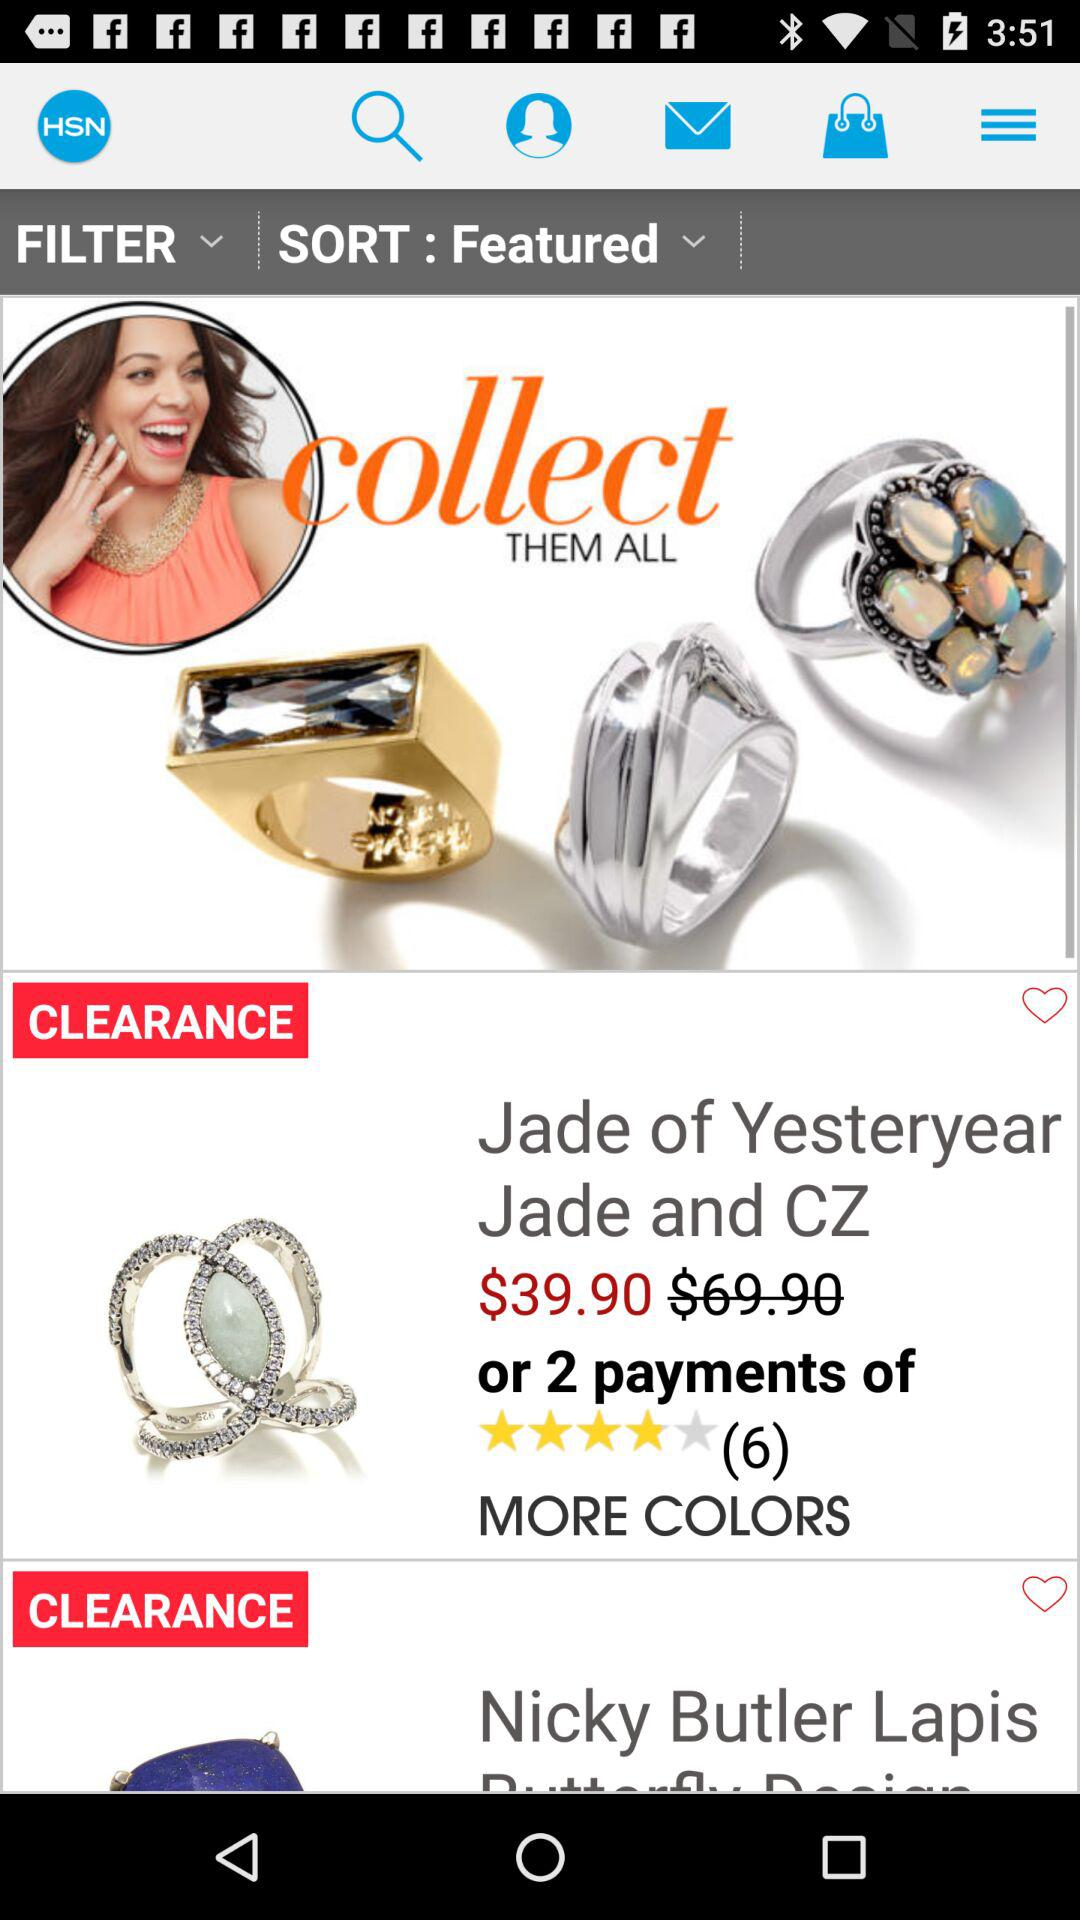What is the application name? The application name is "HSN". 